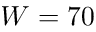Convert formula to latex. <formula><loc_0><loc_0><loc_500><loc_500>W = 7 0</formula> 